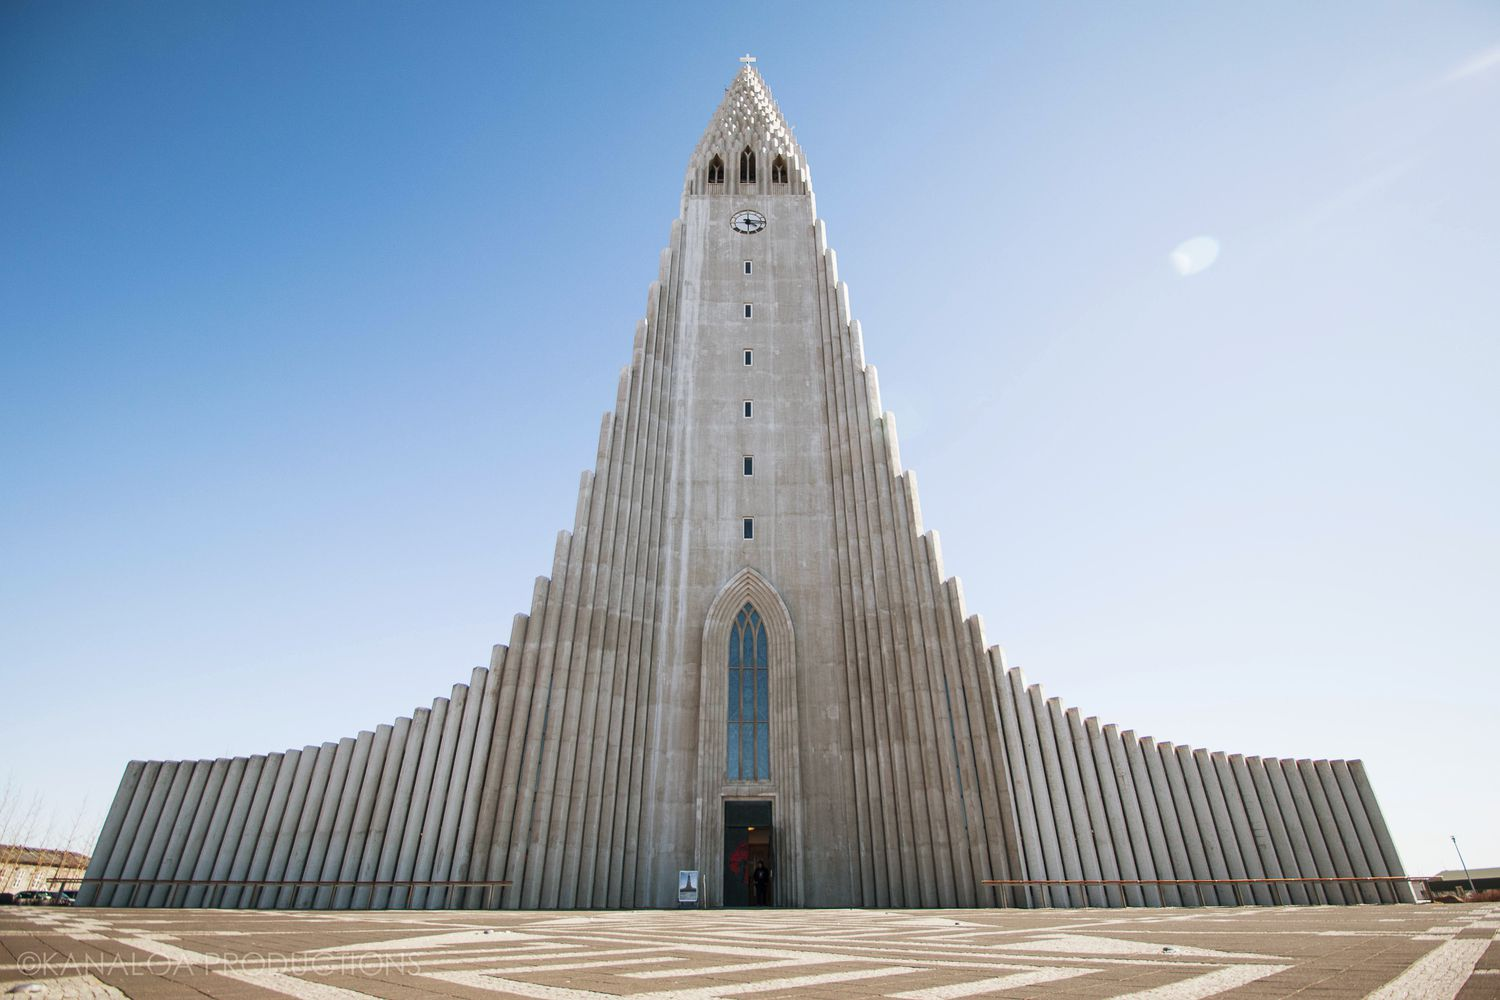Imagine a futuristic scenario involving this church. What might it entail? In a distant future, Hallgrímskirkja is augmented with cutting-edge holographic technology. Visitors can engage in immersive digital experiences, witnessing historical events and hearing ancient hymns as if they were present when the church first opened. The spire, now equipped with advanced sensors, acts as a weather predictor, providing real-time data to the city. Further, the church becomes a hub for interstellar broadcasts, sending messages of peace and culture to distant colonies in outer space. Its role evolves from a local landmark to a beacon of human unity and heritage, connecting Earth with the broader cosmos. 